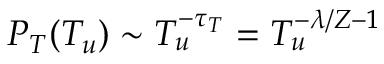Convert formula to latex. <formula><loc_0><loc_0><loc_500><loc_500>P _ { T } ( T _ { u } ) \sim T _ { u } ^ { - \tau _ { T } } = T _ { u } ^ { - \lambda / Z - 1 }</formula> 